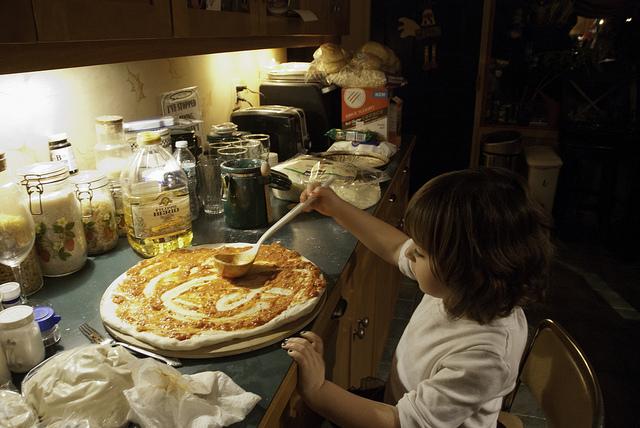Is the table cluttered or tidy?
Quick response, please. Cluttered. What's the kid making?
Keep it brief. Pizza. Are the girls nails polished?
Short answer required. Yes. 